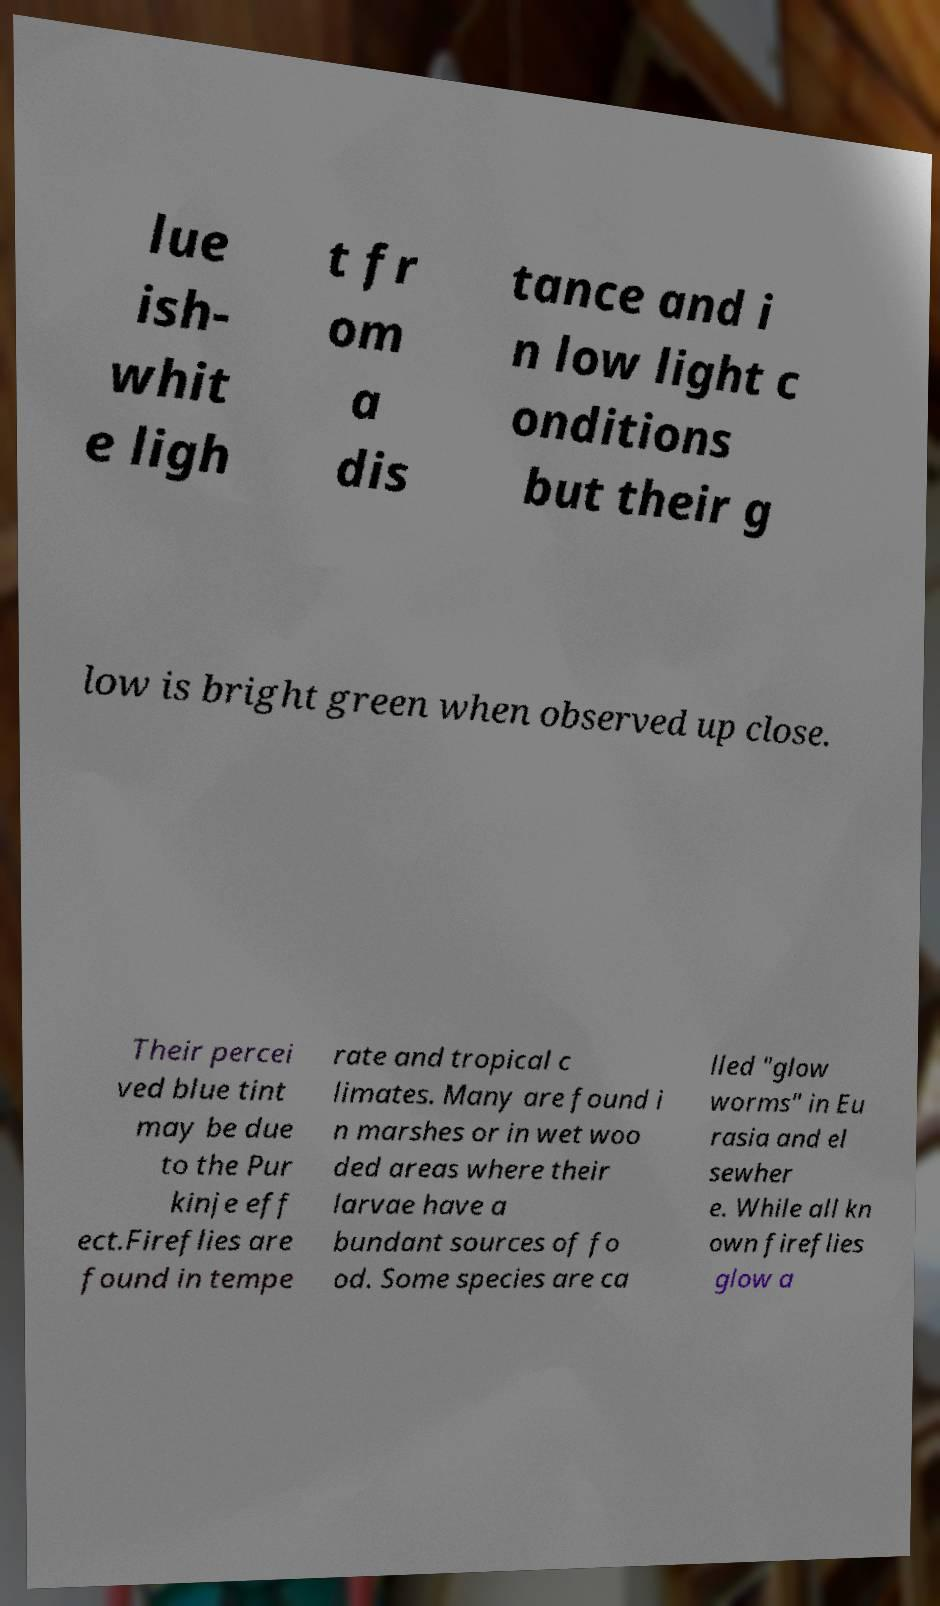Can you accurately transcribe the text from the provided image for me? lue ish- whit e ligh t fr om a dis tance and i n low light c onditions but their g low is bright green when observed up close. Their percei ved blue tint may be due to the Pur kinje eff ect.Fireflies are found in tempe rate and tropical c limates. Many are found i n marshes or in wet woo ded areas where their larvae have a bundant sources of fo od. Some species are ca lled "glow worms" in Eu rasia and el sewher e. While all kn own fireflies glow a 